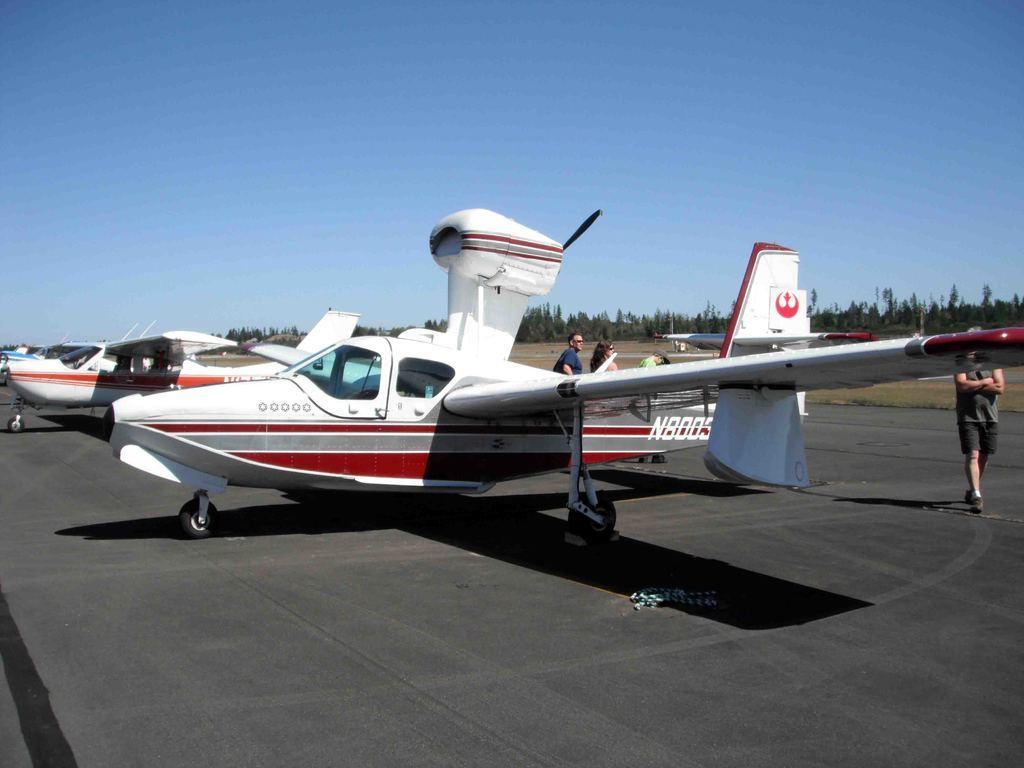Can you describe this image briefly? In the image there are many aeroplanes on the road and behind it there are few persons walking, over the whole background there are trees all over the image and above its sky.. 